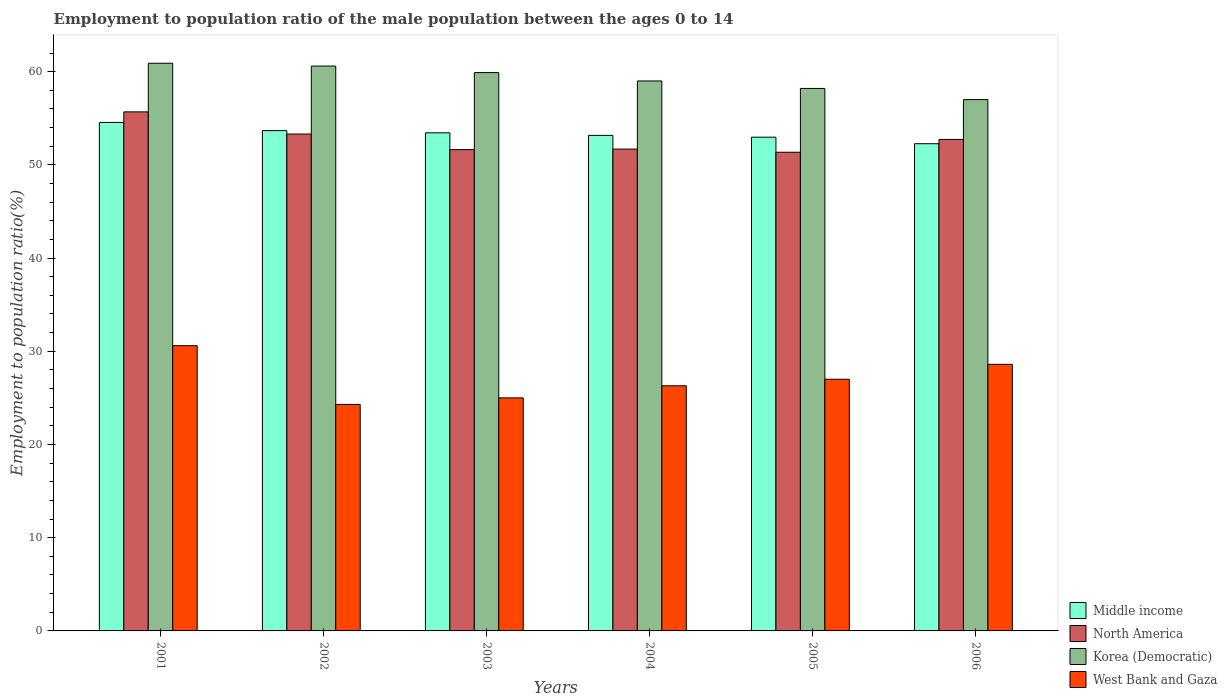How many groups of bars are there?
Your answer should be very brief. 6. How many bars are there on the 6th tick from the right?
Offer a very short reply. 4. What is the label of the 1st group of bars from the left?
Your answer should be very brief. 2001. In how many cases, is the number of bars for a given year not equal to the number of legend labels?
Your response must be concise. 0. What is the employment to population ratio in Middle income in 2002?
Provide a short and direct response. 53.67. Across all years, what is the maximum employment to population ratio in Korea (Democratic)?
Ensure brevity in your answer.  60.9. Across all years, what is the minimum employment to population ratio in Korea (Democratic)?
Your response must be concise. 57. What is the total employment to population ratio in North America in the graph?
Make the answer very short. 316.4. What is the difference between the employment to population ratio in West Bank and Gaza in 2004 and that in 2006?
Provide a short and direct response. -2.3. What is the difference between the employment to population ratio in North America in 2005 and the employment to population ratio in West Bank and Gaza in 2004?
Your answer should be very brief. 25.05. What is the average employment to population ratio in Middle income per year?
Ensure brevity in your answer.  53.34. In the year 2005, what is the difference between the employment to population ratio in North America and employment to population ratio in West Bank and Gaza?
Provide a short and direct response. 24.35. What is the ratio of the employment to population ratio in North America in 2004 to that in 2005?
Offer a terse response. 1.01. What is the difference between the highest and the second highest employment to population ratio in West Bank and Gaza?
Provide a short and direct response. 2. What is the difference between the highest and the lowest employment to population ratio in Korea (Democratic)?
Provide a succinct answer. 3.9. Is the sum of the employment to population ratio in Korea (Democratic) in 2001 and 2003 greater than the maximum employment to population ratio in West Bank and Gaza across all years?
Provide a short and direct response. Yes. Is it the case that in every year, the sum of the employment to population ratio in Korea (Democratic) and employment to population ratio in North America is greater than the sum of employment to population ratio in Middle income and employment to population ratio in West Bank and Gaza?
Offer a very short reply. Yes. What does the 2nd bar from the left in 2002 represents?
Offer a very short reply. North America. What does the 2nd bar from the right in 2002 represents?
Make the answer very short. Korea (Democratic). How many bars are there?
Keep it short and to the point. 24. Are the values on the major ticks of Y-axis written in scientific E-notation?
Make the answer very short. No. Does the graph contain any zero values?
Ensure brevity in your answer.  No. Where does the legend appear in the graph?
Give a very brief answer. Bottom right. How many legend labels are there?
Offer a very short reply. 4. How are the legend labels stacked?
Provide a succinct answer. Vertical. What is the title of the graph?
Make the answer very short. Employment to population ratio of the male population between the ages 0 to 14. Does "Tunisia" appear as one of the legend labels in the graph?
Give a very brief answer. No. What is the label or title of the X-axis?
Keep it short and to the point. Years. What is the Employment to population ratio(%) in Middle income in 2001?
Your response must be concise. 54.55. What is the Employment to population ratio(%) of North America in 2001?
Give a very brief answer. 55.69. What is the Employment to population ratio(%) of Korea (Democratic) in 2001?
Keep it short and to the point. 60.9. What is the Employment to population ratio(%) in West Bank and Gaza in 2001?
Make the answer very short. 30.6. What is the Employment to population ratio(%) in Middle income in 2002?
Ensure brevity in your answer.  53.67. What is the Employment to population ratio(%) of North America in 2002?
Make the answer very short. 53.31. What is the Employment to population ratio(%) of Korea (Democratic) in 2002?
Offer a very short reply. 60.6. What is the Employment to population ratio(%) of West Bank and Gaza in 2002?
Your answer should be compact. 24.3. What is the Employment to population ratio(%) of Middle income in 2003?
Offer a terse response. 53.44. What is the Employment to population ratio(%) in North America in 2003?
Provide a short and direct response. 51.63. What is the Employment to population ratio(%) of Korea (Democratic) in 2003?
Ensure brevity in your answer.  59.9. What is the Employment to population ratio(%) of Middle income in 2004?
Provide a succinct answer. 53.16. What is the Employment to population ratio(%) of North America in 2004?
Your response must be concise. 51.69. What is the Employment to population ratio(%) of West Bank and Gaza in 2004?
Your answer should be very brief. 26.3. What is the Employment to population ratio(%) in Middle income in 2005?
Your answer should be very brief. 52.97. What is the Employment to population ratio(%) in North America in 2005?
Provide a succinct answer. 51.35. What is the Employment to population ratio(%) of Korea (Democratic) in 2005?
Your response must be concise. 58.2. What is the Employment to population ratio(%) in West Bank and Gaza in 2005?
Your answer should be very brief. 27. What is the Employment to population ratio(%) in Middle income in 2006?
Offer a terse response. 52.27. What is the Employment to population ratio(%) in North America in 2006?
Provide a short and direct response. 52.73. What is the Employment to population ratio(%) in Korea (Democratic) in 2006?
Make the answer very short. 57. What is the Employment to population ratio(%) in West Bank and Gaza in 2006?
Your answer should be compact. 28.6. Across all years, what is the maximum Employment to population ratio(%) in Middle income?
Your answer should be very brief. 54.55. Across all years, what is the maximum Employment to population ratio(%) of North America?
Offer a terse response. 55.69. Across all years, what is the maximum Employment to population ratio(%) of Korea (Democratic)?
Ensure brevity in your answer.  60.9. Across all years, what is the maximum Employment to population ratio(%) in West Bank and Gaza?
Your answer should be very brief. 30.6. Across all years, what is the minimum Employment to population ratio(%) of Middle income?
Your answer should be compact. 52.27. Across all years, what is the minimum Employment to population ratio(%) in North America?
Provide a succinct answer. 51.35. Across all years, what is the minimum Employment to population ratio(%) in Korea (Democratic)?
Your answer should be compact. 57. Across all years, what is the minimum Employment to population ratio(%) of West Bank and Gaza?
Provide a short and direct response. 24.3. What is the total Employment to population ratio(%) of Middle income in the graph?
Provide a succinct answer. 320.06. What is the total Employment to population ratio(%) of North America in the graph?
Provide a succinct answer. 316.4. What is the total Employment to population ratio(%) in Korea (Democratic) in the graph?
Provide a succinct answer. 355.6. What is the total Employment to population ratio(%) in West Bank and Gaza in the graph?
Your answer should be very brief. 161.8. What is the difference between the Employment to population ratio(%) in Middle income in 2001 and that in 2002?
Your answer should be very brief. 0.88. What is the difference between the Employment to population ratio(%) of North America in 2001 and that in 2002?
Your response must be concise. 2.38. What is the difference between the Employment to population ratio(%) in Middle income in 2001 and that in 2003?
Give a very brief answer. 1.11. What is the difference between the Employment to population ratio(%) of North America in 2001 and that in 2003?
Keep it short and to the point. 4.05. What is the difference between the Employment to population ratio(%) of Korea (Democratic) in 2001 and that in 2003?
Offer a very short reply. 1. What is the difference between the Employment to population ratio(%) in West Bank and Gaza in 2001 and that in 2003?
Offer a very short reply. 5.6. What is the difference between the Employment to population ratio(%) of Middle income in 2001 and that in 2004?
Your response must be concise. 1.39. What is the difference between the Employment to population ratio(%) of North America in 2001 and that in 2004?
Your response must be concise. 3.99. What is the difference between the Employment to population ratio(%) of Korea (Democratic) in 2001 and that in 2004?
Your answer should be very brief. 1.9. What is the difference between the Employment to population ratio(%) of Middle income in 2001 and that in 2005?
Provide a succinct answer. 1.58. What is the difference between the Employment to population ratio(%) in North America in 2001 and that in 2005?
Offer a very short reply. 4.33. What is the difference between the Employment to population ratio(%) of Korea (Democratic) in 2001 and that in 2005?
Offer a very short reply. 2.7. What is the difference between the Employment to population ratio(%) in Middle income in 2001 and that in 2006?
Offer a very short reply. 2.28. What is the difference between the Employment to population ratio(%) of North America in 2001 and that in 2006?
Ensure brevity in your answer.  2.96. What is the difference between the Employment to population ratio(%) in Middle income in 2002 and that in 2003?
Your answer should be compact. 0.24. What is the difference between the Employment to population ratio(%) of North America in 2002 and that in 2003?
Give a very brief answer. 1.67. What is the difference between the Employment to population ratio(%) of Middle income in 2002 and that in 2004?
Make the answer very short. 0.51. What is the difference between the Employment to population ratio(%) of North America in 2002 and that in 2004?
Your answer should be compact. 1.61. What is the difference between the Employment to population ratio(%) in Korea (Democratic) in 2002 and that in 2004?
Your response must be concise. 1.6. What is the difference between the Employment to population ratio(%) in Middle income in 2002 and that in 2005?
Your answer should be very brief. 0.7. What is the difference between the Employment to population ratio(%) in North America in 2002 and that in 2005?
Offer a terse response. 1.95. What is the difference between the Employment to population ratio(%) in Korea (Democratic) in 2002 and that in 2005?
Offer a very short reply. 2.4. What is the difference between the Employment to population ratio(%) of West Bank and Gaza in 2002 and that in 2005?
Your answer should be very brief. -2.7. What is the difference between the Employment to population ratio(%) in Middle income in 2002 and that in 2006?
Keep it short and to the point. 1.4. What is the difference between the Employment to population ratio(%) of North America in 2002 and that in 2006?
Offer a terse response. 0.58. What is the difference between the Employment to population ratio(%) of West Bank and Gaza in 2002 and that in 2006?
Provide a succinct answer. -4.3. What is the difference between the Employment to population ratio(%) of Middle income in 2003 and that in 2004?
Your answer should be compact. 0.27. What is the difference between the Employment to population ratio(%) in North America in 2003 and that in 2004?
Provide a short and direct response. -0.06. What is the difference between the Employment to population ratio(%) in Korea (Democratic) in 2003 and that in 2004?
Give a very brief answer. 0.9. What is the difference between the Employment to population ratio(%) of Middle income in 2003 and that in 2005?
Offer a terse response. 0.47. What is the difference between the Employment to population ratio(%) in North America in 2003 and that in 2005?
Keep it short and to the point. 0.28. What is the difference between the Employment to population ratio(%) of Korea (Democratic) in 2003 and that in 2005?
Provide a short and direct response. 1.7. What is the difference between the Employment to population ratio(%) in West Bank and Gaza in 2003 and that in 2005?
Keep it short and to the point. -2. What is the difference between the Employment to population ratio(%) of Middle income in 2003 and that in 2006?
Offer a terse response. 1.17. What is the difference between the Employment to population ratio(%) in North America in 2003 and that in 2006?
Offer a terse response. -1.1. What is the difference between the Employment to population ratio(%) of Korea (Democratic) in 2003 and that in 2006?
Ensure brevity in your answer.  2.9. What is the difference between the Employment to population ratio(%) in Middle income in 2004 and that in 2005?
Offer a terse response. 0.19. What is the difference between the Employment to population ratio(%) in North America in 2004 and that in 2005?
Ensure brevity in your answer.  0.34. What is the difference between the Employment to population ratio(%) in Middle income in 2004 and that in 2006?
Give a very brief answer. 0.9. What is the difference between the Employment to population ratio(%) of North America in 2004 and that in 2006?
Make the answer very short. -1.04. What is the difference between the Employment to population ratio(%) in West Bank and Gaza in 2004 and that in 2006?
Offer a very short reply. -2.3. What is the difference between the Employment to population ratio(%) in Middle income in 2005 and that in 2006?
Make the answer very short. 0.7. What is the difference between the Employment to population ratio(%) in North America in 2005 and that in 2006?
Offer a very short reply. -1.38. What is the difference between the Employment to population ratio(%) of Korea (Democratic) in 2005 and that in 2006?
Your answer should be compact. 1.2. What is the difference between the Employment to population ratio(%) in Middle income in 2001 and the Employment to population ratio(%) in North America in 2002?
Make the answer very short. 1.24. What is the difference between the Employment to population ratio(%) in Middle income in 2001 and the Employment to population ratio(%) in Korea (Democratic) in 2002?
Your answer should be very brief. -6.05. What is the difference between the Employment to population ratio(%) in Middle income in 2001 and the Employment to population ratio(%) in West Bank and Gaza in 2002?
Give a very brief answer. 30.25. What is the difference between the Employment to population ratio(%) in North America in 2001 and the Employment to population ratio(%) in Korea (Democratic) in 2002?
Keep it short and to the point. -4.91. What is the difference between the Employment to population ratio(%) of North America in 2001 and the Employment to population ratio(%) of West Bank and Gaza in 2002?
Your response must be concise. 31.39. What is the difference between the Employment to population ratio(%) of Korea (Democratic) in 2001 and the Employment to population ratio(%) of West Bank and Gaza in 2002?
Ensure brevity in your answer.  36.6. What is the difference between the Employment to population ratio(%) in Middle income in 2001 and the Employment to population ratio(%) in North America in 2003?
Offer a very short reply. 2.92. What is the difference between the Employment to population ratio(%) of Middle income in 2001 and the Employment to population ratio(%) of Korea (Democratic) in 2003?
Give a very brief answer. -5.35. What is the difference between the Employment to population ratio(%) of Middle income in 2001 and the Employment to population ratio(%) of West Bank and Gaza in 2003?
Your answer should be compact. 29.55. What is the difference between the Employment to population ratio(%) in North America in 2001 and the Employment to population ratio(%) in Korea (Democratic) in 2003?
Provide a succinct answer. -4.21. What is the difference between the Employment to population ratio(%) in North America in 2001 and the Employment to population ratio(%) in West Bank and Gaza in 2003?
Make the answer very short. 30.69. What is the difference between the Employment to population ratio(%) in Korea (Democratic) in 2001 and the Employment to population ratio(%) in West Bank and Gaza in 2003?
Give a very brief answer. 35.9. What is the difference between the Employment to population ratio(%) in Middle income in 2001 and the Employment to population ratio(%) in North America in 2004?
Give a very brief answer. 2.86. What is the difference between the Employment to population ratio(%) of Middle income in 2001 and the Employment to population ratio(%) of Korea (Democratic) in 2004?
Offer a very short reply. -4.45. What is the difference between the Employment to population ratio(%) in Middle income in 2001 and the Employment to population ratio(%) in West Bank and Gaza in 2004?
Your answer should be compact. 28.25. What is the difference between the Employment to population ratio(%) in North America in 2001 and the Employment to population ratio(%) in Korea (Democratic) in 2004?
Provide a succinct answer. -3.31. What is the difference between the Employment to population ratio(%) in North America in 2001 and the Employment to population ratio(%) in West Bank and Gaza in 2004?
Keep it short and to the point. 29.39. What is the difference between the Employment to population ratio(%) in Korea (Democratic) in 2001 and the Employment to population ratio(%) in West Bank and Gaza in 2004?
Provide a succinct answer. 34.6. What is the difference between the Employment to population ratio(%) of Middle income in 2001 and the Employment to population ratio(%) of North America in 2005?
Keep it short and to the point. 3.2. What is the difference between the Employment to population ratio(%) in Middle income in 2001 and the Employment to population ratio(%) in Korea (Democratic) in 2005?
Provide a short and direct response. -3.65. What is the difference between the Employment to population ratio(%) of Middle income in 2001 and the Employment to population ratio(%) of West Bank and Gaza in 2005?
Your answer should be compact. 27.55. What is the difference between the Employment to population ratio(%) in North America in 2001 and the Employment to population ratio(%) in Korea (Democratic) in 2005?
Make the answer very short. -2.51. What is the difference between the Employment to population ratio(%) in North America in 2001 and the Employment to population ratio(%) in West Bank and Gaza in 2005?
Your answer should be very brief. 28.69. What is the difference between the Employment to population ratio(%) of Korea (Democratic) in 2001 and the Employment to population ratio(%) of West Bank and Gaza in 2005?
Offer a very short reply. 33.9. What is the difference between the Employment to population ratio(%) of Middle income in 2001 and the Employment to population ratio(%) of North America in 2006?
Offer a terse response. 1.82. What is the difference between the Employment to population ratio(%) of Middle income in 2001 and the Employment to population ratio(%) of Korea (Democratic) in 2006?
Your answer should be compact. -2.45. What is the difference between the Employment to population ratio(%) of Middle income in 2001 and the Employment to population ratio(%) of West Bank and Gaza in 2006?
Offer a terse response. 25.95. What is the difference between the Employment to population ratio(%) in North America in 2001 and the Employment to population ratio(%) in Korea (Democratic) in 2006?
Give a very brief answer. -1.31. What is the difference between the Employment to population ratio(%) in North America in 2001 and the Employment to population ratio(%) in West Bank and Gaza in 2006?
Your answer should be very brief. 27.09. What is the difference between the Employment to population ratio(%) in Korea (Democratic) in 2001 and the Employment to population ratio(%) in West Bank and Gaza in 2006?
Your answer should be compact. 32.3. What is the difference between the Employment to population ratio(%) in Middle income in 2002 and the Employment to population ratio(%) in North America in 2003?
Ensure brevity in your answer.  2.04. What is the difference between the Employment to population ratio(%) in Middle income in 2002 and the Employment to population ratio(%) in Korea (Democratic) in 2003?
Offer a very short reply. -6.23. What is the difference between the Employment to population ratio(%) in Middle income in 2002 and the Employment to population ratio(%) in West Bank and Gaza in 2003?
Keep it short and to the point. 28.67. What is the difference between the Employment to population ratio(%) of North America in 2002 and the Employment to population ratio(%) of Korea (Democratic) in 2003?
Your response must be concise. -6.59. What is the difference between the Employment to population ratio(%) in North America in 2002 and the Employment to population ratio(%) in West Bank and Gaza in 2003?
Give a very brief answer. 28.31. What is the difference between the Employment to population ratio(%) in Korea (Democratic) in 2002 and the Employment to population ratio(%) in West Bank and Gaza in 2003?
Your response must be concise. 35.6. What is the difference between the Employment to population ratio(%) of Middle income in 2002 and the Employment to population ratio(%) of North America in 2004?
Make the answer very short. 1.98. What is the difference between the Employment to population ratio(%) in Middle income in 2002 and the Employment to population ratio(%) in Korea (Democratic) in 2004?
Make the answer very short. -5.33. What is the difference between the Employment to population ratio(%) in Middle income in 2002 and the Employment to population ratio(%) in West Bank and Gaza in 2004?
Make the answer very short. 27.37. What is the difference between the Employment to population ratio(%) in North America in 2002 and the Employment to population ratio(%) in Korea (Democratic) in 2004?
Your response must be concise. -5.69. What is the difference between the Employment to population ratio(%) of North America in 2002 and the Employment to population ratio(%) of West Bank and Gaza in 2004?
Ensure brevity in your answer.  27.01. What is the difference between the Employment to population ratio(%) in Korea (Democratic) in 2002 and the Employment to population ratio(%) in West Bank and Gaza in 2004?
Your answer should be very brief. 34.3. What is the difference between the Employment to population ratio(%) of Middle income in 2002 and the Employment to population ratio(%) of North America in 2005?
Provide a succinct answer. 2.32. What is the difference between the Employment to population ratio(%) of Middle income in 2002 and the Employment to population ratio(%) of Korea (Democratic) in 2005?
Keep it short and to the point. -4.53. What is the difference between the Employment to population ratio(%) of Middle income in 2002 and the Employment to population ratio(%) of West Bank and Gaza in 2005?
Offer a terse response. 26.67. What is the difference between the Employment to population ratio(%) of North America in 2002 and the Employment to population ratio(%) of Korea (Democratic) in 2005?
Offer a very short reply. -4.89. What is the difference between the Employment to population ratio(%) in North America in 2002 and the Employment to population ratio(%) in West Bank and Gaza in 2005?
Offer a very short reply. 26.31. What is the difference between the Employment to population ratio(%) of Korea (Democratic) in 2002 and the Employment to population ratio(%) of West Bank and Gaza in 2005?
Provide a succinct answer. 33.6. What is the difference between the Employment to population ratio(%) in Middle income in 2002 and the Employment to population ratio(%) in North America in 2006?
Your answer should be very brief. 0.95. What is the difference between the Employment to population ratio(%) of Middle income in 2002 and the Employment to population ratio(%) of Korea (Democratic) in 2006?
Provide a succinct answer. -3.33. What is the difference between the Employment to population ratio(%) of Middle income in 2002 and the Employment to population ratio(%) of West Bank and Gaza in 2006?
Your answer should be very brief. 25.07. What is the difference between the Employment to population ratio(%) of North America in 2002 and the Employment to population ratio(%) of Korea (Democratic) in 2006?
Keep it short and to the point. -3.69. What is the difference between the Employment to population ratio(%) in North America in 2002 and the Employment to population ratio(%) in West Bank and Gaza in 2006?
Ensure brevity in your answer.  24.71. What is the difference between the Employment to population ratio(%) of Korea (Democratic) in 2002 and the Employment to population ratio(%) of West Bank and Gaza in 2006?
Offer a terse response. 32. What is the difference between the Employment to population ratio(%) in Middle income in 2003 and the Employment to population ratio(%) in North America in 2004?
Ensure brevity in your answer.  1.74. What is the difference between the Employment to population ratio(%) of Middle income in 2003 and the Employment to population ratio(%) of Korea (Democratic) in 2004?
Keep it short and to the point. -5.56. What is the difference between the Employment to population ratio(%) in Middle income in 2003 and the Employment to population ratio(%) in West Bank and Gaza in 2004?
Your answer should be very brief. 27.14. What is the difference between the Employment to population ratio(%) in North America in 2003 and the Employment to population ratio(%) in Korea (Democratic) in 2004?
Provide a short and direct response. -7.37. What is the difference between the Employment to population ratio(%) in North America in 2003 and the Employment to population ratio(%) in West Bank and Gaza in 2004?
Your answer should be compact. 25.33. What is the difference between the Employment to population ratio(%) in Korea (Democratic) in 2003 and the Employment to population ratio(%) in West Bank and Gaza in 2004?
Ensure brevity in your answer.  33.6. What is the difference between the Employment to population ratio(%) of Middle income in 2003 and the Employment to population ratio(%) of North America in 2005?
Your answer should be compact. 2.08. What is the difference between the Employment to population ratio(%) in Middle income in 2003 and the Employment to population ratio(%) in Korea (Democratic) in 2005?
Keep it short and to the point. -4.76. What is the difference between the Employment to population ratio(%) in Middle income in 2003 and the Employment to population ratio(%) in West Bank and Gaza in 2005?
Give a very brief answer. 26.44. What is the difference between the Employment to population ratio(%) in North America in 2003 and the Employment to population ratio(%) in Korea (Democratic) in 2005?
Provide a succinct answer. -6.57. What is the difference between the Employment to population ratio(%) in North America in 2003 and the Employment to population ratio(%) in West Bank and Gaza in 2005?
Your answer should be very brief. 24.63. What is the difference between the Employment to population ratio(%) in Korea (Democratic) in 2003 and the Employment to population ratio(%) in West Bank and Gaza in 2005?
Ensure brevity in your answer.  32.9. What is the difference between the Employment to population ratio(%) of Middle income in 2003 and the Employment to population ratio(%) of North America in 2006?
Offer a terse response. 0.71. What is the difference between the Employment to population ratio(%) of Middle income in 2003 and the Employment to population ratio(%) of Korea (Democratic) in 2006?
Offer a terse response. -3.56. What is the difference between the Employment to population ratio(%) of Middle income in 2003 and the Employment to population ratio(%) of West Bank and Gaza in 2006?
Your answer should be compact. 24.84. What is the difference between the Employment to population ratio(%) in North America in 2003 and the Employment to population ratio(%) in Korea (Democratic) in 2006?
Provide a short and direct response. -5.37. What is the difference between the Employment to population ratio(%) of North America in 2003 and the Employment to population ratio(%) of West Bank and Gaza in 2006?
Ensure brevity in your answer.  23.03. What is the difference between the Employment to population ratio(%) of Korea (Democratic) in 2003 and the Employment to population ratio(%) of West Bank and Gaza in 2006?
Your response must be concise. 31.3. What is the difference between the Employment to population ratio(%) of Middle income in 2004 and the Employment to population ratio(%) of North America in 2005?
Keep it short and to the point. 1.81. What is the difference between the Employment to population ratio(%) of Middle income in 2004 and the Employment to population ratio(%) of Korea (Democratic) in 2005?
Your response must be concise. -5.04. What is the difference between the Employment to population ratio(%) of Middle income in 2004 and the Employment to population ratio(%) of West Bank and Gaza in 2005?
Give a very brief answer. 26.16. What is the difference between the Employment to population ratio(%) in North America in 2004 and the Employment to population ratio(%) in Korea (Democratic) in 2005?
Give a very brief answer. -6.51. What is the difference between the Employment to population ratio(%) in North America in 2004 and the Employment to population ratio(%) in West Bank and Gaza in 2005?
Your answer should be compact. 24.69. What is the difference between the Employment to population ratio(%) of Middle income in 2004 and the Employment to population ratio(%) of North America in 2006?
Your response must be concise. 0.44. What is the difference between the Employment to population ratio(%) in Middle income in 2004 and the Employment to population ratio(%) in Korea (Democratic) in 2006?
Provide a succinct answer. -3.84. What is the difference between the Employment to population ratio(%) of Middle income in 2004 and the Employment to population ratio(%) of West Bank and Gaza in 2006?
Your answer should be very brief. 24.56. What is the difference between the Employment to population ratio(%) of North America in 2004 and the Employment to population ratio(%) of Korea (Democratic) in 2006?
Give a very brief answer. -5.31. What is the difference between the Employment to population ratio(%) in North America in 2004 and the Employment to population ratio(%) in West Bank and Gaza in 2006?
Your answer should be very brief. 23.09. What is the difference between the Employment to population ratio(%) of Korea (Democratic) in 2004 and the Employment to population ratio(%) of West Bank and Gaza in 2006?
Your answer should be compact. 30.4. What is the difference between the Employment to population ratio(%) in Middle income in 2005 and the Employment to population ratio(%) in North America in 2006?
Ensure brevity in your answer.  0.24. What is the difference between the Employment to population ratio(%) in Middle income in 2005 and the Employment to population ratio(%) in Korea (Democratic) in 2006?
Make the answer very short. -4.03. What is the difference between the Employment to population ratio(%) of Middle income in 2005 and the Employment to population ratio(%) of West Bank and Gaza in 2006?
Keep it short and to the point. 24.37. What is the difference between the Employment to population ratio(%) of North America in 2005 and the Employment to population ratio(%) of Korea (Democratic) in 2006?
Provide a succinct answer. -5.65. What is the difference between the Employment to population ratio(%) in North America in 2005 and the Employment to population ratio(%) in West Bank and Gaza in 2006?
Provide a short and direct response. 22.75. What is the difference between the Employment to population ratio(%) in Korea (Democratic) in 2005 and the Employment to population ratio(%) in West Bank and Gaza in 2006?
Your answer should be very brief. 29.6. What is the average Employment to population ratio(%) in Middle income per year?
Your answer should be compact. 53.34. What is the average Employment to population ratio(%) of North America per year?
Your response must be concise. 52.73. What is the average Employment to population ratio(%) in Korea (Democratic) per year?
Offer a very short reply. 59.27. What is the average Employment to population ratio(%) of West Bank and Gaza per year?
Provide a short and direct response. 26.97. In the year 2001, what is the difference between the Employment to population ratio(%) in Middle income and Employment to population ratio(%) in North America?
Provide a succinct answer. -1.13. In the year 2001, what is the difference between the Employment to population ratio(%) of Middle income and Employment to population ratio(%) of Korea (Democratic)?
Offer a very short reply. -6.35. In the year 2001, what is the difference between the Employment to population ratio(%) in Middle income and Employment to population ratio(%) in West Bank and Gaza?
Make the answer very short. 23.95. In the year 2001, what is the difference between the Employment to population ratio(%) of North America and Employment to population ratio(%) of Korea (Democratic)?
Your response must be concise. -5.21. In the year 2001, what is the difference between the Employment to population ratio(%) in North America and Employment to population ratio(%) in West Bank and Gaza?
Offer a very short reply. 25.09. In the year 2001, what is the difference between the Employment to population ratio(%) in Korea (Democratic) and Employment to population ratio(%) in West Bank and Gaza?
Make the answer very short. 30.3. In the year 2002, what is the difference between the Employment to population ratio(%) of Middle income and Employment to population ratio(%) of North America?
Offer a terse response. 0.37. In the year 2002, what is the difference between the Employment to population ratio(%) in Middle income and Employment to population ratio(%) in Korea (Democratic)?
Provide a short and direct response. -6.93. In the year 2002, what is the difference between the Employment to population ratio(%) of Middle income and Employment to population ratio(%) of West Bank and Gaza?
Ensure brevity in your answer.  29.37. In the year 2002, what is the difference between the Employment to population ratio(%) of North America and Employment to population ratio(%) of Korea (Democratic)?
Keep it short and to the point. -7.29. In the year 2002, what is the difference between the Employment to population ratio(%) in North America and Employment to population ratio(%) in West Bank and Gaza?
Your answer should be very brief. 29.01. In the year 2002, what is the difference between the Employment to population ratio(%) of Korea (Democratic) and Employment to population ratio(%) of West Bank and Gaza?
Provide a succinct answer. 36.3. In the year 2003, what is the difference between the Employment to population ratio(%) of Middle income and Employment to population ratio(%) of North America?
Offer a very short reply. 1.8. In the year 2003, what is the difference between the Employment to population ratio(%) in Middle income and Employment to population ratio(%) in Korea (Democratic)?
Keep it short and to the point. -6.46. In the year 2003, what is the difference between the Employment to population ratio(%) in Middle income and Employment to population ratio(%) in West Bank and Gaza?
Offer a very short reply. 28.44. In the year 2003, what is the difference between the Employment to population ratio(%) of North America and Employment to population ratio(%) of Korea (Democratic)?
Provide a succinct answer. -8.27. In the year 2003, what is the difference between the Employment to population ratio(%) in North America and Employment to population ratio(%) in West Bank and Gaza?
Ensure brevity in your answer.  26.63. In the year 2003, what is the difference between the Employment to population ratio(%) in Korea (Democratic) and Employment to population ratio(%) in West Bank and Gaza?
Provide a short and direct response. 34.9. In the year 2004, what is the difference between the Employment to population ratio(%) in Middle income and Employment to population ratio(%) in North America?
Provide a short and direct response. 1.47. In the year 2004, what is the difference between the Employment to population ratio(%) of Middle income and Employment to population ratio(%) of Korea (Democratic)?
Your response must be concise. -5.84. In the year 2004, what is the difference between the Employment to population ratio(%) of Middle income and Employment to population ratio(%) of West Bank and Gaza?
Provide a short and direct response. 26.86. In the year 2004, what is the difference between the Employment to population ratio(%) in North America and Employment to population ratio(%) in Korea (Democratic)?
Keep it short and to the point. -7.31. In the year 2004, what is the difference between the Employment to population ratio(%) of North America and Employment to population ratio(%) of West Bank and Gaza?
Ensure brevity in your answer.  25.39. In the year 2004, what is the difference between the Employment to population ratio(%) in Korea (Democratic) and Employment to population ratio(%) in West Bank and Gaza?
Your response must be concise. 32.7. In the year 2005, what is the difference between the Employment to population ratio(%) of Middle income and Employment to population ratio(%) of North America?
Your answer should be compact. 1.62. In the year 2005, what is the difference between the Employment to population ratio(%) of Middle income and Employment to population ratio(%) of Korea (Democratic)?
Keep it short and to the point. -5.23. In the year 2005, what is the difference between the Employment to population ratio(%) in Middle income and Employment to population ratio(%) in West Bank and Gaza?
Your answer should be very brief. 25.97. In the year 2005, what is the difference between the Employment to population ratio(%) of North America and Employment to population ratio(%) of Korea (Democratic)?
Provide a succinct answer. -6.85. In the year 2005, what is the difference between the Employment to population ratio(%) in North America and Employment to population ratio(%) in West Bank and Gaza?
Offer a very short reply. 24.35. In the year 2005, what is the difference between the Employment to population ratio(%) in Korea (Democratic) and Employment to population ratio(%) in West Bank and Gaza?
Your answer should be compact. 31.2. In the year 2006, what is the difference between the Employment to population ratio(%) of Middle income and Employment to population ratio(%) of North America?
Your answer should be compact. -0.46. In the year 2006, what is the difference between the Employment to population ratio(%) in Middle income and Employment to population ratio(%) in Korea (Democratic)?
Your answer should be very brief. -4.73. In the year 2006, what is the difference between the Employment to population ratio(%) in Middle income and Employment to population ratio(%) in West Bank and Gaza?
Keep it short and to the point. 23.67. In the year 2006, what is the difference between the Employment to population ratio(%) in North America and Employment to population ratio(%) in Korea (Democratic)?
Give a very brief answer. -4.27. In the year 2006, what is the difference between the Employment to population ratio(%) in North America and Employment to population ratio(%) in West Bank and Gaza?
Your response must be concise. 24.13. In the year 2006, what is the difference between the Employment to population ratio(%) in Korea (Democratic) and Employment to population ratio(%) in West Bank and Gaza?
Your answer should be very brief. 28.4. What is the ratio of the Employment to population ratio(%) in Middle income in 2001 to that in 2002?
Ensure brevity in your answer.  1.02. What is the ratio of the Employment to population ratio(%) in North America in 2001 to that in 2002?
Your answer should be very brief. 1.04. What is the ratio of the Employment to population ratio(%) of West Bank and Gaza in 2001 to that in 2002?
Make the answer very short. 1.26. What is the ratio of the Employment to population ratio(%) in Middle income in 2001 to that in 2003?
Your response must be concise. 1.02. What is the ratio of the Employment to population ratio(%) in North America in 2001 to that in 2003?
Give a very brief answer. 1.08. What is the ratio of the Employment to population ratio(%) of Korea (Democratic) in 2001 to that in 2003?
Your response must be concise. 1.02. What is the ratio of the Employment to population ratio(%) in West Bank and Gaza in 2001 to that in 2003?
Ensure brevity in your answer.  1.22. What is the ratio of the Employment to population ratio(%) in Middle income in 2001 to that in 2004?
Offer a terse response. 1.03. What is the ratio of the Employment to population ratio(%) of North America in 2001 to that in 2004?
Give a very brief answer. 1.08. What is the ratio of the Employment to population ratio(%) in Korea (Democratic) in 2001 to that in 2004?
Give a very brief answer. 1.03. What is the ratio of the Employment to population ratio(%) in West Bank and Gaza in 2001 to that in 2004?
Offer a very short reply. 1.16. What is the ratio of the Employment to population ratio(%) in Middle income in 2001 to that in 2005?
Make the answer very short. 1.03. What is the ratio of the Employment to population ratio(%) in North America in 2001 to that in 2005?
Offer a terse response. 1.08. What is the ratio of the Employment to population ratio(%) of Korea (Democratic) in 2001 to that in 2005?
Give a very brief answer. 1.05. What is the ratio of the Employment to population ratio(%) of West Bank and Gaza in 2001 to that in 2005?
Your response must be concise. 1.13. What is the ratio of the Employment to population ratio(%) in Middle income in 2001 to that in 2006?
Offer a terse response. 1.04. What is the ratio of the Employment to population ratio(%) in North America in 2001 to that in 2006?
Give a very brief answer. 1.06. What is the ratio of the Employment to population ratio(%) in Korea (Democratic) in 2001 to that in 2006?
Ensure brevity in your answer.  1.07. What is the ratio of the Employment to population ratio(%) in West Bank and Gaza in 2001 to that in 2006?
Your answer should be very brief. 1.07. What is the ratio of the Employment to population ratio(%) of North America in 2002 to that in 2003?
Your answer should be very brief. 1.03. What is the ratio of the Employment to population ratio(%) in Korea (Democratic) in 2002 to that in 2003?
Provide a succinct answer. 1.01. What is the ratio of the Employment to population ratio(%) in Middle income in 2002 to that in 2004?
Offer a terse response. 1.01. What is the ratio of the Employment to population ratio(%) in North America in 2002 to that in 2004?
Your answer should be compact. 1.03. What is the ratio of the Employment to population ratio(%) of Korea (Democratic) in 2002 to that in 2004?
Offer a terse response. 1.03. What is the ratio of the Employment to population ratio(%) in West Bank and Gaza in 2002 to that in 2004?
Offer a very short reply. 0.92. What is the ratio of the Employment to population ratio(%) in Middle income in 2002 to that in 2005?
Your answer should be compact. 1.01. What is the ratio of the Employment to population ratio(%) of North America in 2002 to that in 2005?
Provide a succinct answer. 1.04. What is the ratio of the Employment to population ratio(%) in Korea (Democratic) in 2002 to that in 2005?
Keep it short and to the point. 1.04. What is the ratio of the Employment to population ratio(%) in Middle income in 2002 to that in 2006?
Offer a very short reply. 1.03. What is the ratio of the Employment to population ratio(%) of North America in 2002 to that in 2006?
Your response must be concise. 1.01. What is the ratio of the Employment to population ratio(%) in Korea (Democratic) in 2002 to that in 2006?
Your response must be concise. 1.06. What is the ratio of the Employment to population ratio(%) of West Bank and Gaza in 2002 to that in 2006?
Ensure brevity in your answer.  0.85. What is the ratio of the Employment to population ratio(%) of Middle income in 2003 to that in 2004?
Your answer should be compact. 1.01. What is the ratio of the Employment to population ratio(%) in North America in 2003 to that in 2004?
Give a very brief answer. 1. What is the ratio of the Employment to population ratio(%) of Korea (Democratic) in 2003 to that in 2004?
Your answer should be compact. 1.02. What is the ratio of the Employment to population ratio(%) in West Bank and Gaza in 2003 to that in 2004?
Make the answer very short. 0.95. What is the ratio of the Employment to population ratio(%) of Middle income in 2003 to that in 2005?
Your response must be concise. 1.01. What is the ratio of the Employment to population ratio(%) in Korea (Democratic) in 2003 to that in 2005?
Offer a terse response. 1.03. What is the ratio of the Employment to population ratio(%) in West Bank and Gaza in 2003 to that in 2005?
Make the answer very short. 0.93. What is the ratio of the Employment to population ratio(%) of Middle income in 2003 to that in 2006?
Ensure brevity in your answer.  1.02. What is the ratio of the Employment to population ratio(%) in North America in 2003 to that in 2006?
Keep it short and to the point. 0.98. What is the ratio of the Employment to population ratio(%) in Korea (Democratic) in 2003 to that in 2006?
Ensure brevity in your answer.  1.05. What is the ratio of the Employment to population ratio(%) in West Bank and Gaza in 2003 to that in 2006?
Provide a succinct answer. 0.87. What is the ratio of the Employment to population ratio(%) in North America in 2004 to that in 2005?
Provide a succinct answer. 1.01. What is the ratio of the Employment to population ratio(%) of Korea (Democratic) in 2004 to that in 2005?
Make the answer very short. 1.01. What is the ratio of the Employment to population ratio(%) in West Bank and Gaza in 2004 to that in 2005?
Give a very brief answer. 0.97. What is the ratio of the Employment to population ratio(%) in Middle income in 2004 to that in 2006?
Keep it short and to the point. 1.02. What is the ratio of the Employment to population ratio(%) of North America in 2004 to that in 2006?
Provide a succinct answer. 0.98. What is the ratio of the Employment to population ratio(%) of Korea (Democratic) in 2004 to that in 2006?
Make the answer very short. 1.04. What is the ratio of the Employment to population ratio(%) in West Bank and Gaza in 2004 to that in 2006?
Provide a short and direct response. 0.92. What is the ratio of the Employment to population ratio(%) in Middle income in 2005 to that in 2006?
Offer a terse response. 1.01. What is the ratio of the Employment to population ratio(%) of North America in 2005 to that in 2006?
Your response must be concise. 0.97. What is the ratio of the Employment to population ratio(%) in Korea (Democratic) in 2005 to that in 2006?
Ensure brevity in your answer.  1.02. What is the ratio of the Employment to population ratio(%) of West Bank and Gaza in 2005 to that in 2006?
Your answer should be very brief. 0.94. What is the difference between the highest and the second highest Employment to population ratio(%) of Middle income?
Provide a short and direct response. 0.88. What is the difference between the highest and the second highest Employment to population ratio(%) in North America?
Your answer should be compact. 2.38. What is the difference between the highest and the lowest Employment to population ratio(%) in Middle income?
Ensure brevity in your answer.  2.28. What is the difference between the highest and the lowest Employment to population ratio(%) in North America?
Keep it short and to the point. 4.33. What is the difference between the highest and the lowest Employment to population ratio(%) of Korea (Democratic)?
Provide a succinct answer. 3.9. 